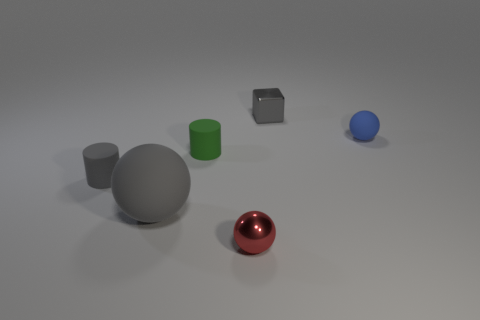Is there a small metal object behind the tiny thing that is to the left of the big matte sphere?
Offer a terse response. Yes. What is the color of the small rubber thing right of the small green object?
Provide a short and direct response. Blue. Are there an equal number of red things that are behind the red sphere and red metal things?
Offer a very short reply. No. What is the shape of the gray thing that is behind the big object and left of the small cube?
Offer a terse response. Cylinder. There is another tiny thing that is the same shape as the tiny green rubber object; what is its color?
Keep it short and to the point. Gray. Are there any other things of the same color as the small metal sphere?
Your answer should be very brief. No. What shape is the shiny object to the right of the small ball to the left of the gray object on the right side of the small red metallic sphere?
Provide a succinct answer. Cube. There is a ball that is on the right side of the gray cube; is it the same size as the cylinder to the left of the green rubber object?
Keep it short and to the point. Yes. How many other cubes are the same material as the cube?
Your answer should be very brief. 0. There is a tiny gray thing in front of the object that is to the right of the gray shiny cube; how many small blue matte objects are to the left of it?
Provide a short and direct response. 0. 